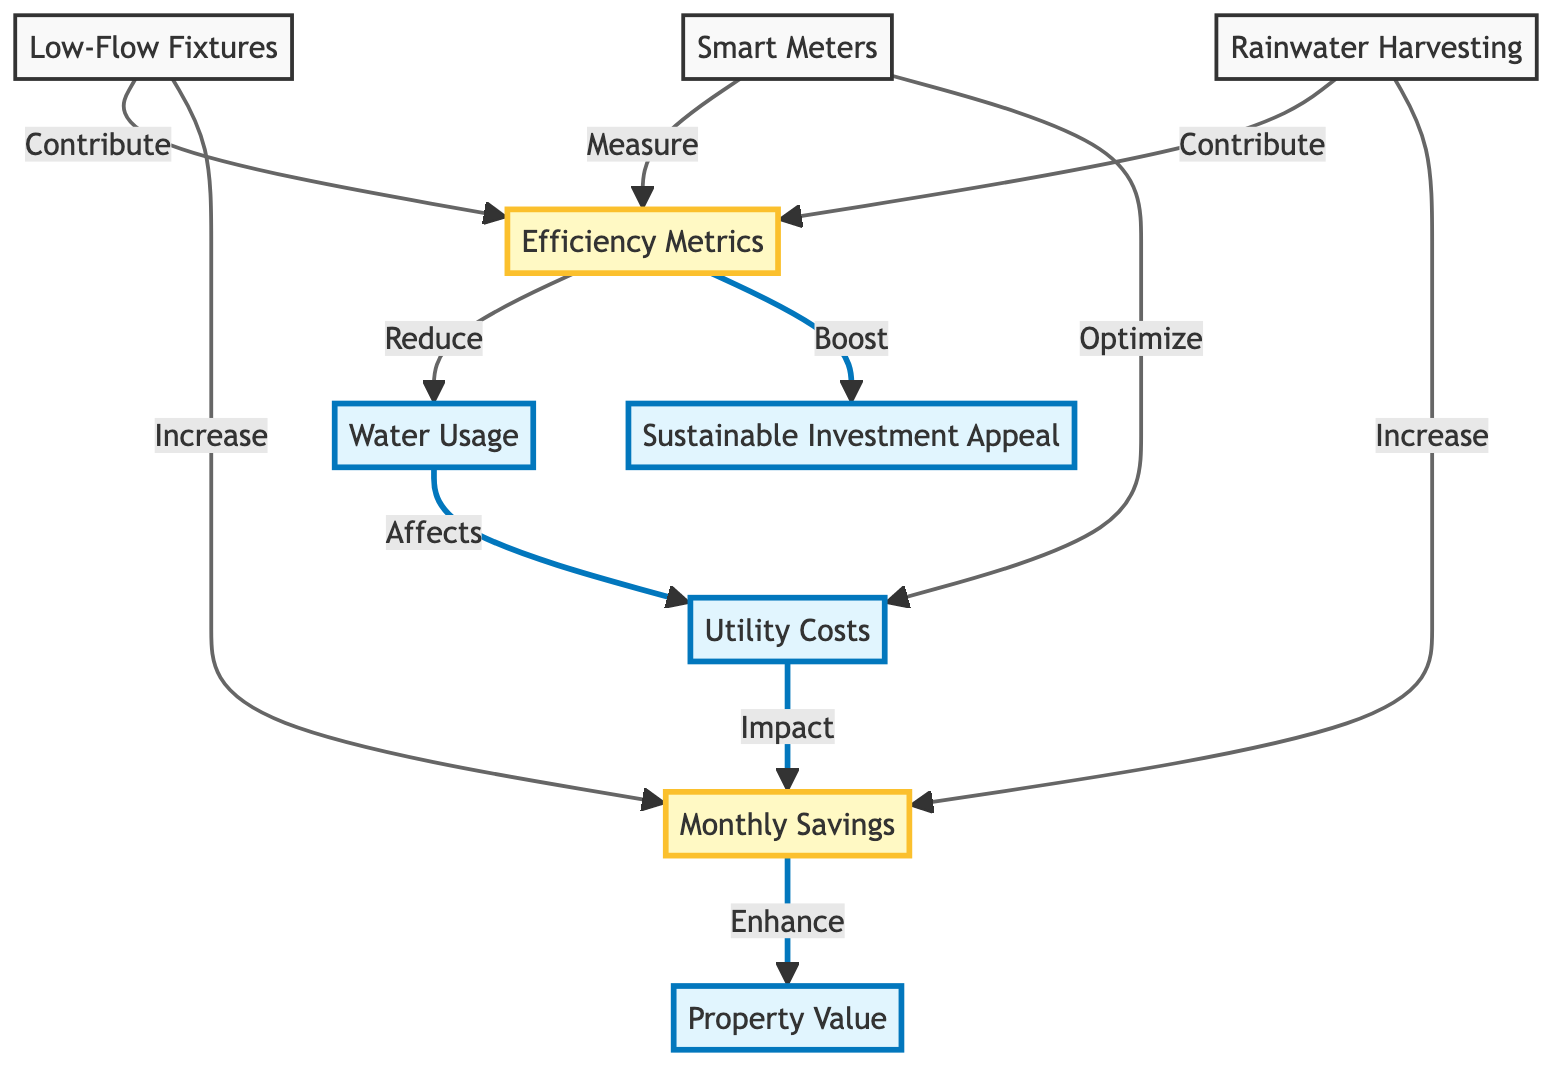What are the primary factors that contribute to efficiency metrics? The diagram shows that low-flow fixtures and rainwater harvesting contribute to efficiency metrics. Both are directly connected to the efficiency metrics node.
Answer: Low-Flow Fixtures, Rainwater Harvesting How does water usage affect utility costs? According to the diagram, water usage directly affects utility costs. This is indicated by the connection between the water usage node and the utility costs node.
Answer: Affects What is the impact of efficiency metrics on sustainable investment? The diagram indicates that efficiency metrics boost sustainable investment. This connection is shown from the efficiency metrics node to the sustainable investment appeal node.
Answer: Boost Which elements increase monthly savings? The diagram demonstrates that low-flow fixtures and rainwater harvesting increase monthly savings. Both are shown with direct arrows to the monthly savings node.
Answer: Low-Flow Fixtures, Rainwater Harvesting How do smart meters interact with efficiency metrics? The diagram shows that smart meters measure efficiency metrics, meaning they play a role in identifying or monitoring how efficiently water is being used.
Answer: Measure What effect do monthly savings have on property value? According to the diagram, monthly savings enhance property value, indicating that more savings lead to higher property valuations. This is demonstrated by the arrow from the monthly savings node to the property value node.
Answer: Enhance Which node is directly connected to both utility costs and monthly savings? The diagram indicates that utility costs are directly connected to monthly savings, showing a clear relationship between the two nodes.
Answer: Utility Costs How many nodes are in the diagram? The diagram consists of a total of ten distinct nodes as captured in the visual representation. Counting them gives us the total number of nodes present.
Answer: Ten What kind of fixtures are suggested to improve efficiency metrics? The diagram suggests low-flow fixtures as a way to contribute to efficiency metrics, showing their importance in improving water efficiency in the property context.
Answer: Low-Flow Fixtures 